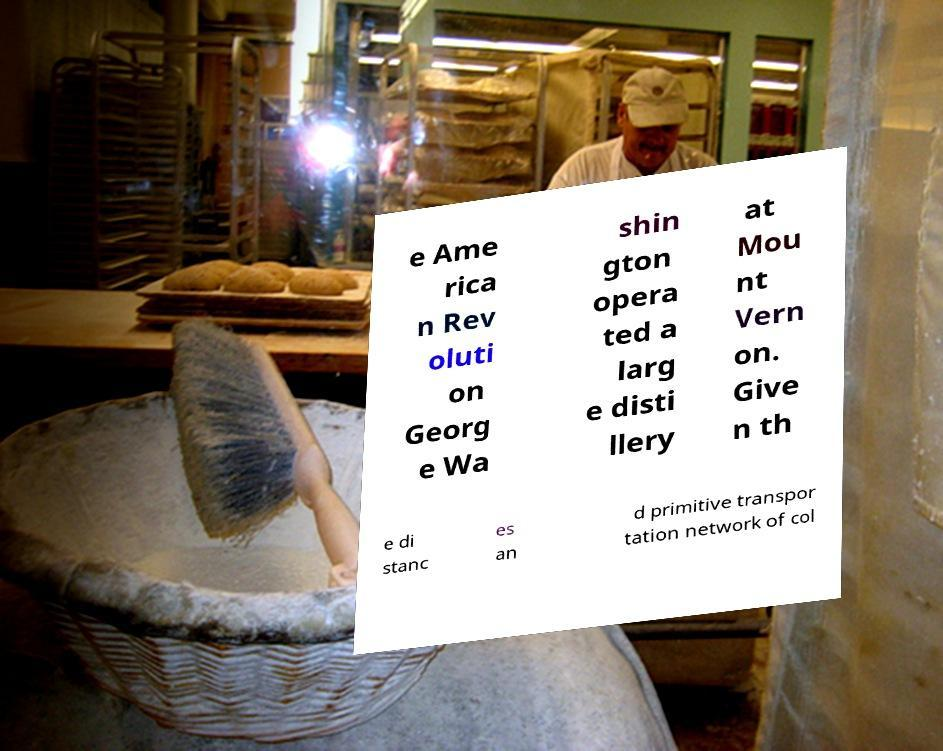Please read and relay the text visible in this image. What does it say? e Ame rica n Rev oluti on Georg e Wa shin gton opera ted a larg e disti llery at Mou nt Vern on. Give n th e di stanc es an d primitive transpor tation network of col 